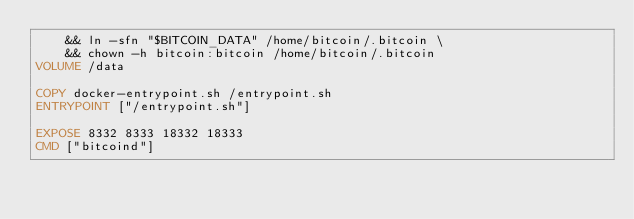Convert code to text. <code><loc_0><loc_0><loc_500><loc_500><_Dockerfile_>	&& ln -sfn "$BITCOIN_DATA" /home/bitcoin/.bitcoin \
	&& chown -h bitcoin:bitcoin /home/bitcoin/.bitcoin
VOLUME /data

COPY docker-entrypoint.sh /entrypoint.sh
ENTRYPOINT ["/entrypoint.sh"]

EXPOSE 8332 8333 18332 18333
CMD ["bitcoind"]
</code> 